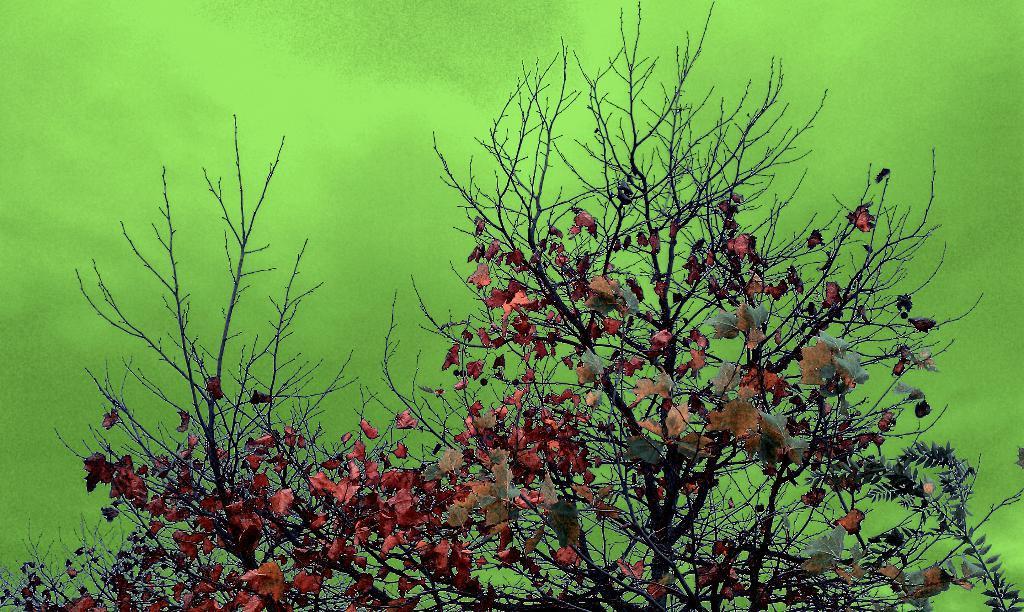Could you give a brief overview of what you see in this image? In the image there is a tree with stems, branches and leaves. And there is a green color background. 